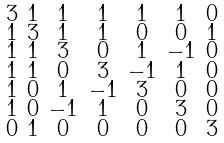Convert formula to latex. <formula><loc_0><loc_0><loc_500><loc_500>\begin{smallmatrix} 3 & 1 & 1 & 1 & 1 & 1 & 0 \\ 1 & 3 & 1 & 1 & 0 & 0 & 1 \\ 1 & 1 & 3 & 0 & 1 & - 1 & 0 \\ 1 & 1 & 0 & 3 & - 1 & 1 & 0 \\ 1 & 0 & 1 & - 1 & 3 & 0 & 0 \\ 1 & 0 & - 1 & 1 & 0 & 3 & 0 \\ 0 & 1 & 0 & 0 & 0 & 0 & 3 \end{smallmatrix}</formula> 